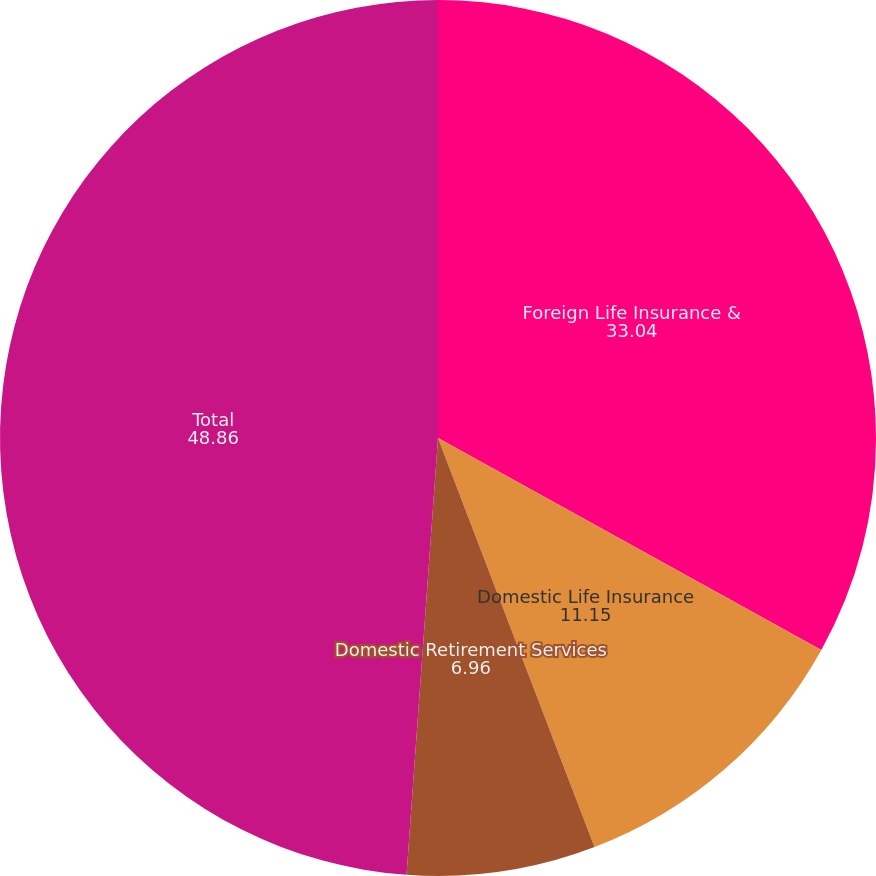<chart> <loc_0><loc_0><loc_500><loc_500><pie_chart><fcel>Foreign Life Insurance &<fcel>Domestic Life Insurance<fcel>Domestic Retirement Services<fcel>Total<nl><fcel>33.04%<fcel>11.15%<fcel>6.96%<fcel>48.86%<nl></chart> 